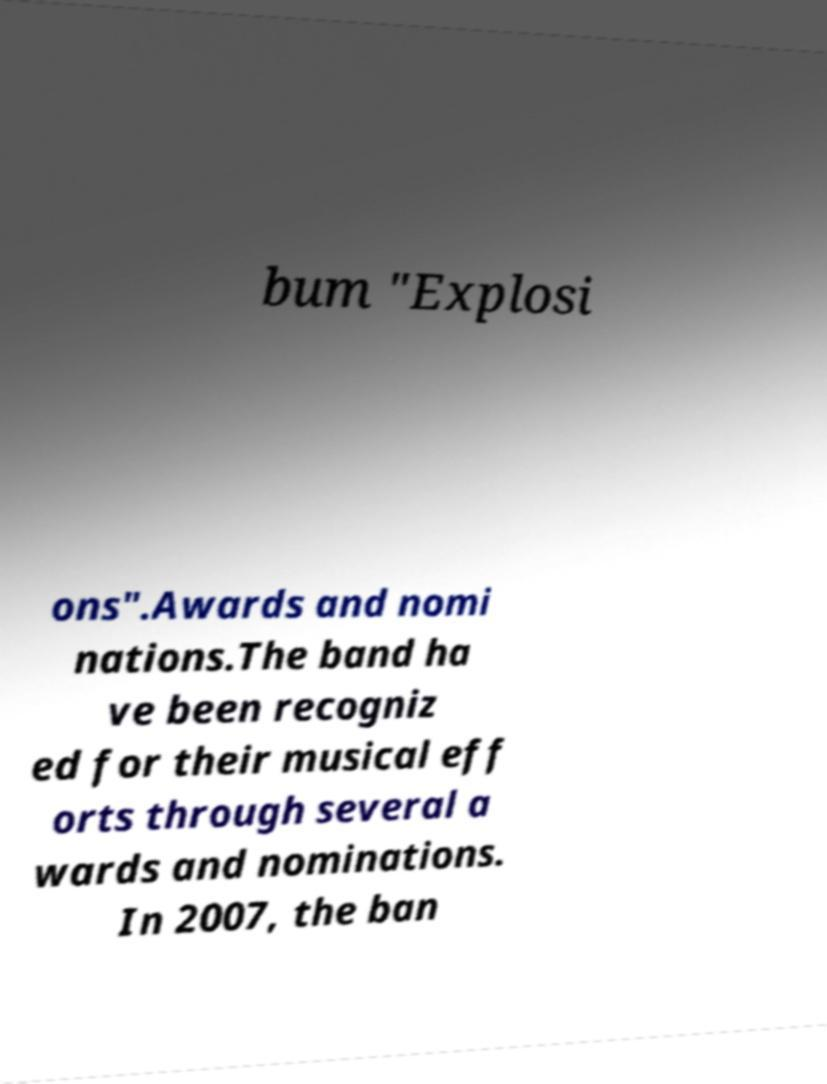Could you assist in decoding the text presented in this image and type it out clearly? bum "Explosi ons".Awards and nomi nations.The band ha ve been recogniz ed for their musical eff orts through several a wards and nominations. In 2007, the ban 